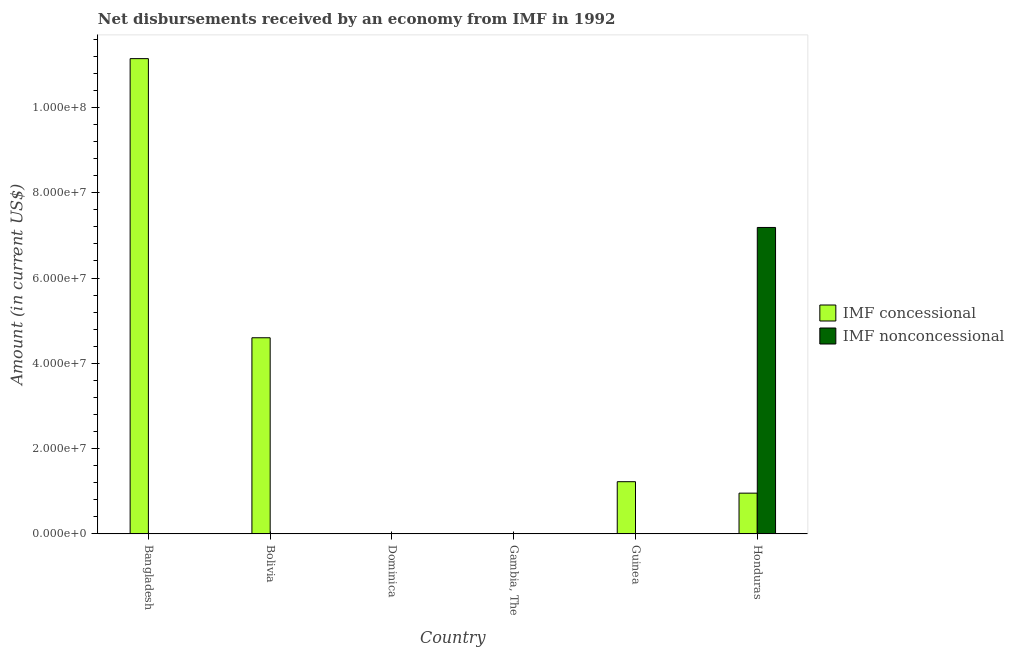How many different coloured bars are there?
Make the answer very short. 2. Are the number of bars on each tick of the X-axis equal?
Your answer should be compact. No. How many bars are there on the 4th tick from the right?
Offer a terse response. 0. What is the label of the 5th group of bars from the left?
Provide a short and direct response. Guinea. In how many cases, is the number of bars for a given country not equal to the number of legend labels?
Provide a succinct answer. 5. Across all countries, what is the maximum net non concessional disbursements from imf?
Make the answer very short. 7.19e+07. Across all countries, what is the minimum net non concessional disbursements from imf?
Provide a succinct answer. 0. What is the total net non concessional disbursements from imf in the graph?
Give a very brief answer. 7.19e+07. What is the difference between the net concessional disbursements from imf in Bolivia and the net non concessional disbursements from imf in Dominica?
Your response must be concise. 4.60e+07. What is the average net non concessional disbursements from imf per country?
Your response must be concise. 1.20e+07. In how many countries, is the net concessional disbursements from imf greater than 20000000 US$?
Your answer should be compact. 2. What is the difference between the highest and the second highest net concessional disbursements from imf?
Offer a very short reply. 6.55e+07. What is the difference between the highest and the lowest net non concessional disbursements from imf?
Your response must be concise. 7.19e+07. In how many countries, is the net concessional disbursements from imf greater than the average net concessional disbursements from imf taken over all countries?
Ensure brevity in your answer.  2. Are all the bars in the graph horizontal?
Make the answer very short. No. How many countries are there in the graph?
Provide a short and direct response. 6. Does the graph contain any zero values?
Your answer should be compact. Yes. Does the graph contain grids?
Provide a short and direct response. No. Where does the legend appear in the graph?
Your answer should be very brief. Center right. How many legend labels are there?
Keep it short and to the point. 2. How are the legend labels stacked?
Offer a terse response. Vertical. What is the title of the graph?
Your answer should be very brief. Net disbursements received by an economy from IMF in 1992. What is the label or title of the X-axis?
Your answer should be very brief. Country. What is the Amount (in current US$) of IMF concessional in Bangladesh?
Provide a succinct answer. 1.11e+08. What is the Amount (in current US$) of IMF concessional in Bolivia?
Keep it short and to the point. 4.60e+07. What is the Amount (in current US$) in IMF nonconcessional in Bolivia?
Your response must be concise. 0. What is the Amount (in current US$) of IMF concessional in Dominica?
Ensure brevity in your answer.  0. What is the Amount (in current US$) in IMF nonconcessional in Dominica?
Offer a terse response. 0. What is the Amount (in current US$) of IMF concessional in Gambia, The?
Ensure brevity in your answer.  0. What is the Amount (in current US$) of IMF concessional in Guinea?
Provide a short and direct response. 1.22e+07. What is the Amount (in current US$) of IMF concessional in Honduras?
Ensure brevity in your answer.  9.55e+06. What is the Amount (in current US$) of IMF nonconcessional in Honduras?
Give a very brief answer. 7.19e+07. Across all countries, what is the maximum Amount (in current US$) in IMF concessional?
Make the answer very short. 1.11e+08. Across all countries, what is the maximum Amount (in current US$) of IMF nonconcessional?
Offer a very short reply. 7.19e+07. Across all countries, what is the minimum Amount (in current US$) in IMF nonconcessional?
Keep it short and to the point. 0. What is the total Amount (in current US$) in IMF concessional in the graph?
Make the answer very short. 1.79e+08. What is the total Amount (in current US$) in IMF nonconcessional in the graph?
Offer a very short reply. 7.19e+07. What is the difference between the Amount (in current US$) of IMF concessional in Bangladesh and that in Bolivia?
Make the answer very short. 6.55e+07. What is the difference between the Amount (in current US$) in IMF concessional in Bangladesh and that in Guinea?
Offer a terse response. 9.92e+07. What is the difference between the Amount (in current US$) in IMF concessional in Bangladesh and that in Honduras?
Provide a succinct answer. 1.02e+08. What is the difference between the Amount (in current US$) of IMF concessional in Bolivia and that in Guinea?
Offer a very short reply. 3.38e+07. What is the difference between the Amount (in current US$) of IMF concessional in Bolivia and that in Honduras?
Offer a terse response. 3.64e+07. What is the difference between the Amount (in current US$) of IMF concessional in Guinea and that in Honduras?
Ensure brevity in your answer.  2.68e+06. What is the difference between the Amount (in current US$) of IMF concessional in Bangladesh and the Amount (in current US$) of IMF nonconcessional in Honduras?
Your answer should be very brief. 3.96e+07. What is the difference between the Amount (in current US$) in IMF concessional in Bolivia and the Amount (in current US$) in IMF nonconcessional in Honduras?
Provide a short and direct response. -2.59e+07. What is the difference between the Amount (in current US$) of IMF concessional in Guinea and the Amount (in current US$) of IMF nonconcessional in Honduras?
Your response must be concise. -5.96e+07. What is the average Amount (in current US$) in IMF concessional per country?
Offer a very short reply. 2.99e+07. What is the average Amount (in current US$) in IMF nonconcessional per country?
Provide a succinct answer. 1.20e+07. What is the difference between the Amount (in current US$) in IMF concessional and Amount (in current US$) in IMF nonconcessional in Honduras?
Offer a terse response. -6.23e+07. What is the ratio of the Amount (in current US$) in IMF concessional in Bangladesh to that in Bolivia?
Make the answer very short. 2.42. What is the ratio of the Amount (in current US$) of IMF concessional in Bangladesh to that in Guinea?
Your response must be concise. 9.11. What is the ratio of the Amount (in current US$) of IMF concessional in Bangladesh to that in Honduras?
Your answer should be very brief. 11.67. What is the ratio of the Amount (in current US$) in IMF concessional in Bolivia to that in Guinea?
Your answer should be very brief. 3.76. What is the ratio of the Amount (in current US$) of IMF concessional in Bolivia to that in Honduras?
Make the answer very short. 4.82. What is the ratio of the Amount (in current US$) in IMF concessional in Guinea to that in Honduras?
Ensure brevity in your answer.  1.28. What is the difference between the highest and the second highest Amount (in current US$) in IMF concessional?
Offer a terse response. 6.55e+07. What is the difference between the highest and the lowest Amount (in current US$) in IMF concessional?
Offer a terse response. 1.11e+08. What is the difference between the highest and the lowest Amount (in current US$) in IMF nonconcessional?
Give a very brief answer. 7.19e+07. 